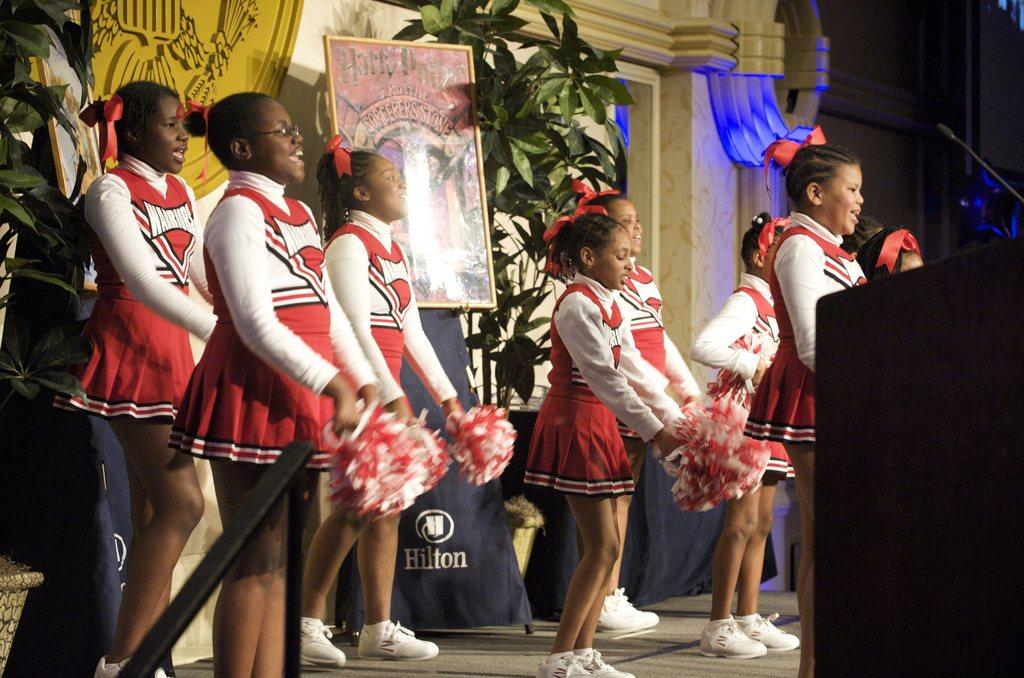<image>
Describe the image concisely. Warriors cheerleaders perform a routine in front of a Harry Potter poster. 